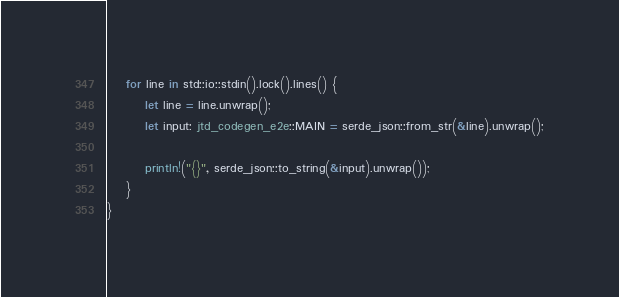<code> <loc_0><loc_0><loc_500><loc_500><_Rust_>    for line in std::io::stdin().lock().lines() {
        let line = line.unwrap();
        let input: jtd_codegen_e2e::MAIN = serde_json::from_str(&line).unwrap();

        println!("{}", serde_json::to_string(&input).unwrap());
    }
}
</code> 